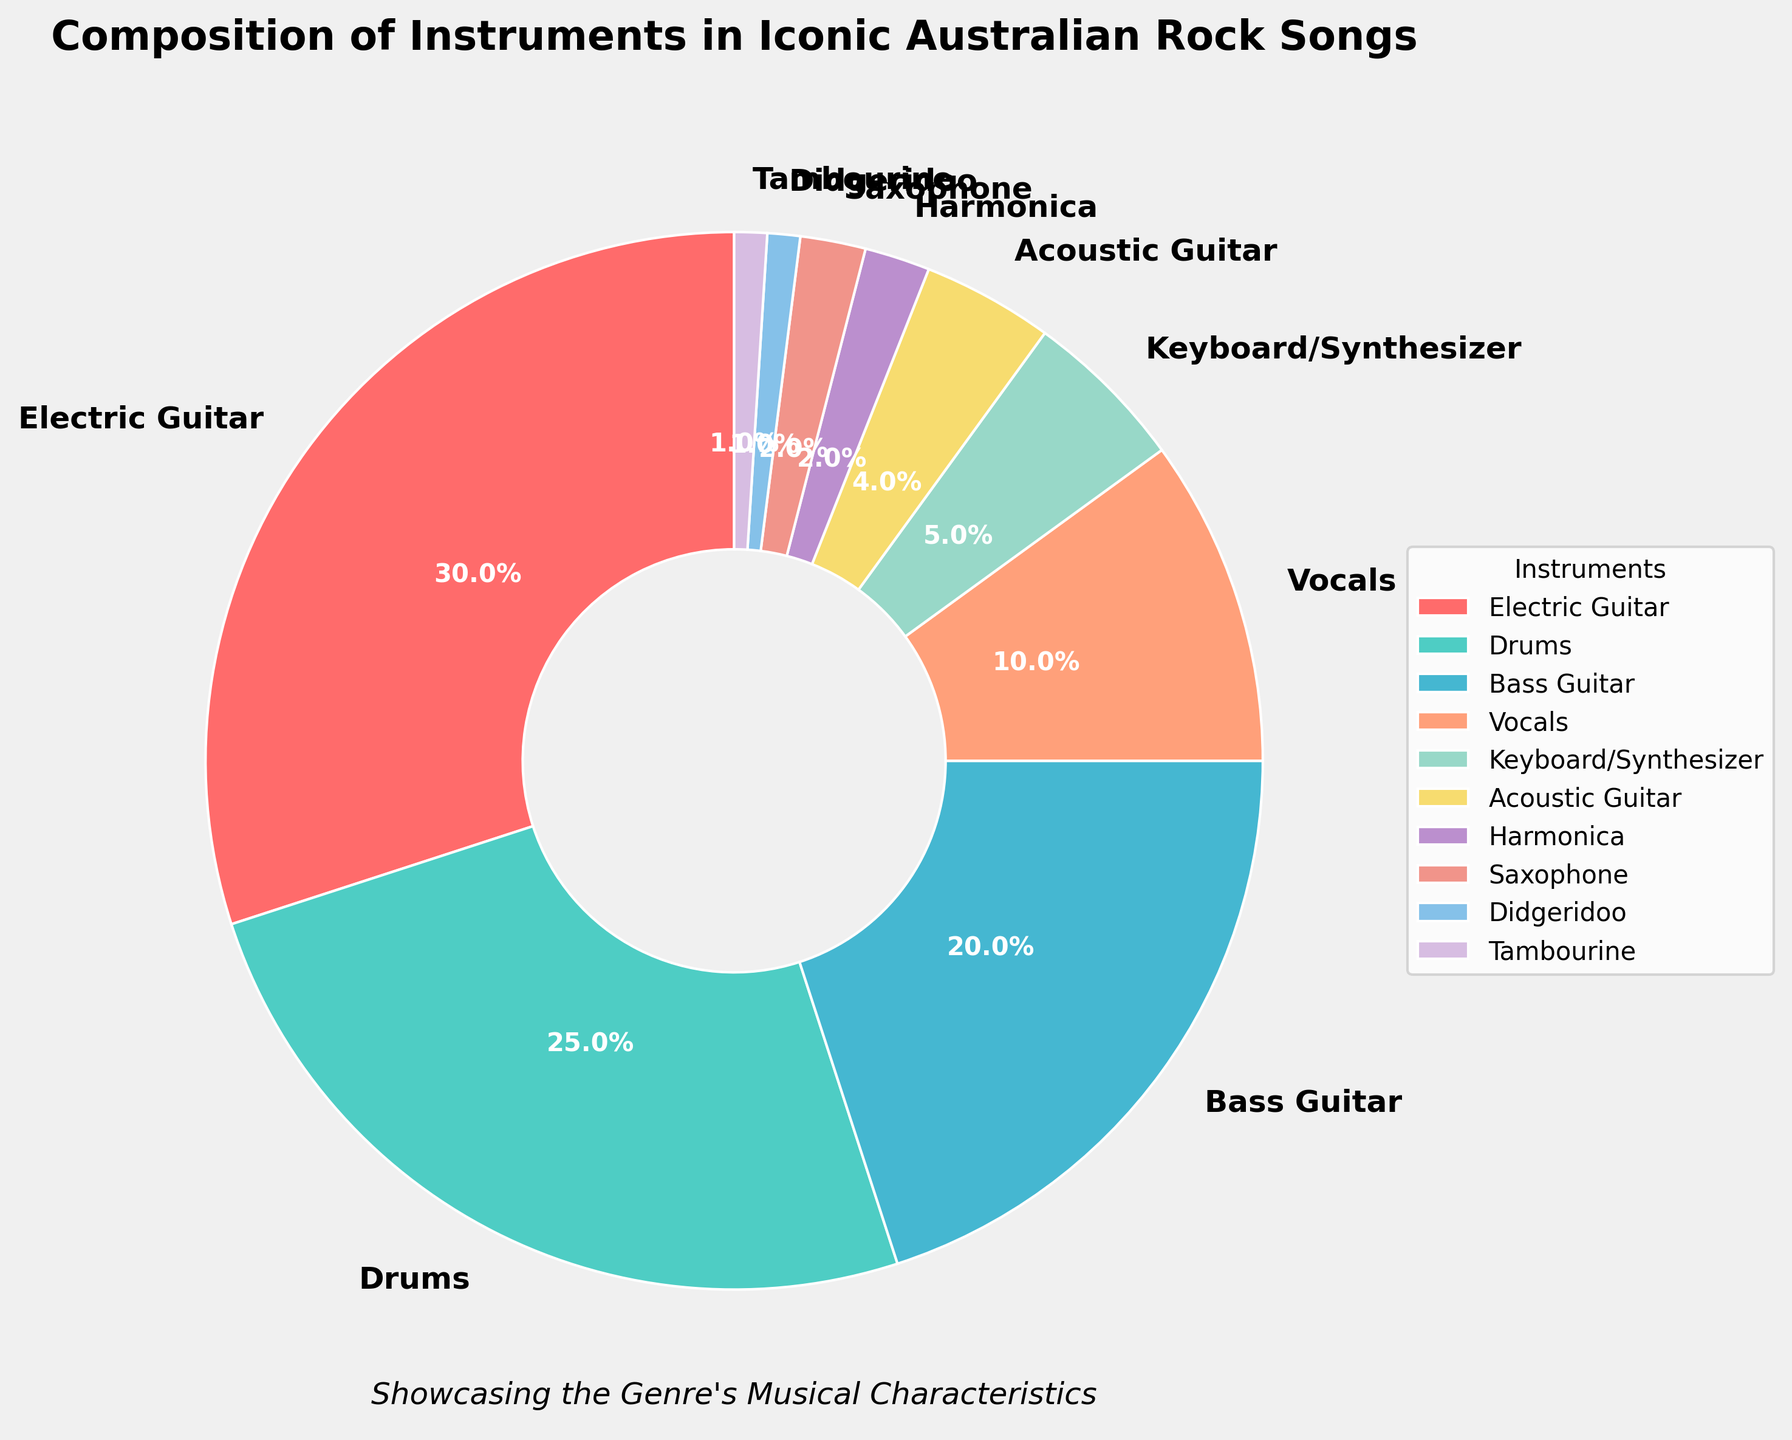Which instrument holds the highest percentage in iconic Australian rock songs? In the pie chart, the "Electric Guitar" slice is the largest, with a label of 30%, indicating it holds the highest percentage.
Answer: Electric Guitar Which two instruments collectively make up 45% of the composition? Combining "Electric Guitar" (30%) and "Drums" (25%), the total is 30% + 25% = 55%, so adjust to "Bass Guitar" (20%) and "Drums" (25%), which make up 45%.
Answer: Bass Guitar and Drums How does the percentage of Drums compare to that of Bass Guitar? The pie chart shows "Drums" at 25% and "Bass Guitar" at 20%. Since 25% is greater than 20%, drums have a higher percentage.
Answer: Drums has a higher percentage than Bass Guitar What is the difference in percentage between the instrument with the highest representation and the one with the second highest? The highest percentage is held by "Electric Guitar" at 30%, and the second highest is "Drums" at 25%. The difference is 30% - 25% = 5%.
Answer: 5% How are the percentages of Harmonica and Saxophone in iconic Australian rock songs related? Both "Harmonica" and "Saxophone" slices show 2%, illustrating they each have the same percentage.
Answer: The same What is the combined percentage of Acoustic Guitar, Didgeridoo, and Tambourine? Summing the percentages, "Acoustic Guitar" (4%), "Didgeridoo" (1%), and "Tambourine" (1%) is 4% + 1% + 1% = 6%.
Answer: 6% Among the listed instruments, which one has the lowest percentage representation? According to the chart, both "Didgeridoo" and "Tambourine" are tied at the lowest percentage representation of 1% each.
Answer: Didgeridoo and Tambourine Which group collectively makes up over half of the composition by percentage? Adding up "Electric Guitar" (30%), "Drums" (25%), and "Bass Guitar" (20%) totals to 30% + 25% + 20% = 75%, which is over half.
Answer: Electric Guitar, Drums, and Bass Guitar If you were to remove Electric Guitar from the chart, what would be the new highest percentage instrument? Without "Electric Guitar" (30%), the new highest percentage would be "Drums" at 25%.
Answer: Drums What is the median percentage of the instruments listed? Median is the middle value when values are listed in order. The sorted percentages are 1, 1, 2, 2, 4, 5, 10, 20, 25, 30. The middle values are 4 and 5, median is (4+5)/2 = 4.5.
Answer: 4.5% 